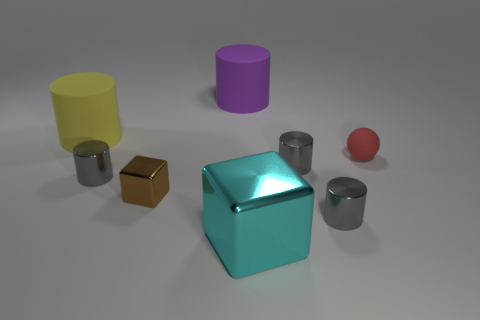What size is the brown object that is the same shape as the cyan thing?
Ensure brevity in your answer.  Small. There is a cylinder that is left of the small brown thing and on the right side of the large yellow rubber cylinder; what is its size?
Keep it short and to the point. Small. There is a metallic cube that is left of the big cyan metallic block; how big is it?
Offer a terse response. Small. Is the material of the large thing in front of the yellow thing the same as the tiny brown thing?
Keep it short and to the point. Yes. Are there fewer small metal things in front of the brown metallic object than metal blocks?
Keep it short and to the point. Yes. What number of metallic objects are either small cyan things or small things?
Make the answer very short. 4. Is the small matte thing the same color as the big block?
Offer a terse response. No. Is there anything else that is the same color as the tiny rubber thing?
Keep it short and to the point. No. There is a large matte thing that is on the right side of the brown metal object; is its shape the same as the big thing in front of the small red thing?
Offer a very short reply. No. What number of things are gray things or tiny gray shiny cylinders that are left of the big cyan block?
Make the answer very short. 3. 